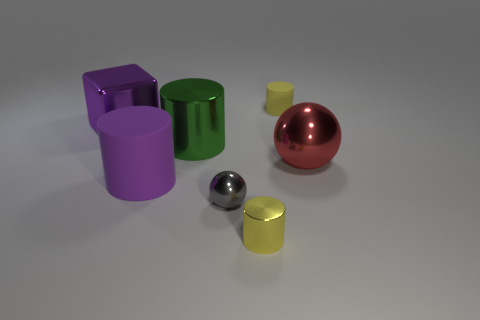What color is the metal sphere that is the same size as the yellow matte cylinder?
Offer a terse response. Gray. What number of blue objects are tiny metallic spheres or large metallic cubes?
Ensure brevity in your answer.  0. Are there more small yellow matte balls than big purple matte cylinders?
Your response must be concise. No. There is a yellow cylinder that is on the left side of the yellow rubber cylinder; does it have the same size as the purple object behind the big red metallic ball?
Offer a terse response. No. There is a matte cylinder left of the yellow thing that is in front of the big cylinder that is behind the big sphere; what is its color?
Your answer should be compact. Purple. Is there a gray thing of the same shape as the yellow rubber object?
Your response must be concise. No. Is the number of purple shiny things right of the tiny gray sphere greater than the number of metal spheres?
Provide a succinct answer. No. How many metal things are either green objects or gray objects?
Provide a succinct answer. 2. How big is the thing that is on the left side of the yellow metal thing and behind the large green object?
Provide a succinct answer. Large. Are there any large purple objects that are in front of the big shiny thing that is on the left side of the big green cylinder?
Provide a short and direct response. Yes. 